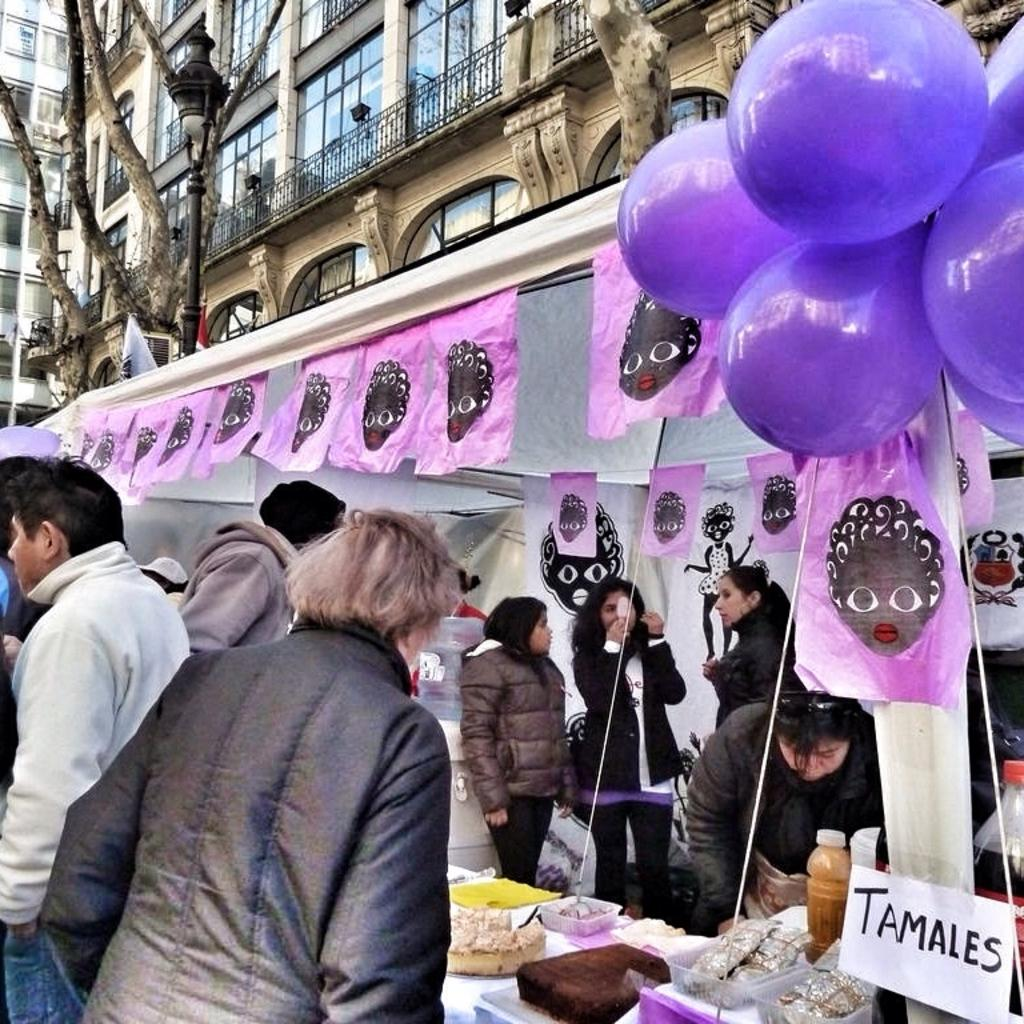What are the people in the image wearing? The people in the image are wearing jackets. What can be seen in the image besides the people? There is a stall of food, balloons, a building, a street light, and a tree in the image. What might be sold at the food stall in the image? The specific items being sold at the food stall are not visible in the image, but it is a stall of food. What type of structure is present in the image? There is a building in the image. What is used to provide light at night in the image? There is a street light in the image. What type of plant is present in the image? There is a tree in the image. How many times does the fifth person pull the brake in the image? There is no mention of a fifth person or a brake in the image. 